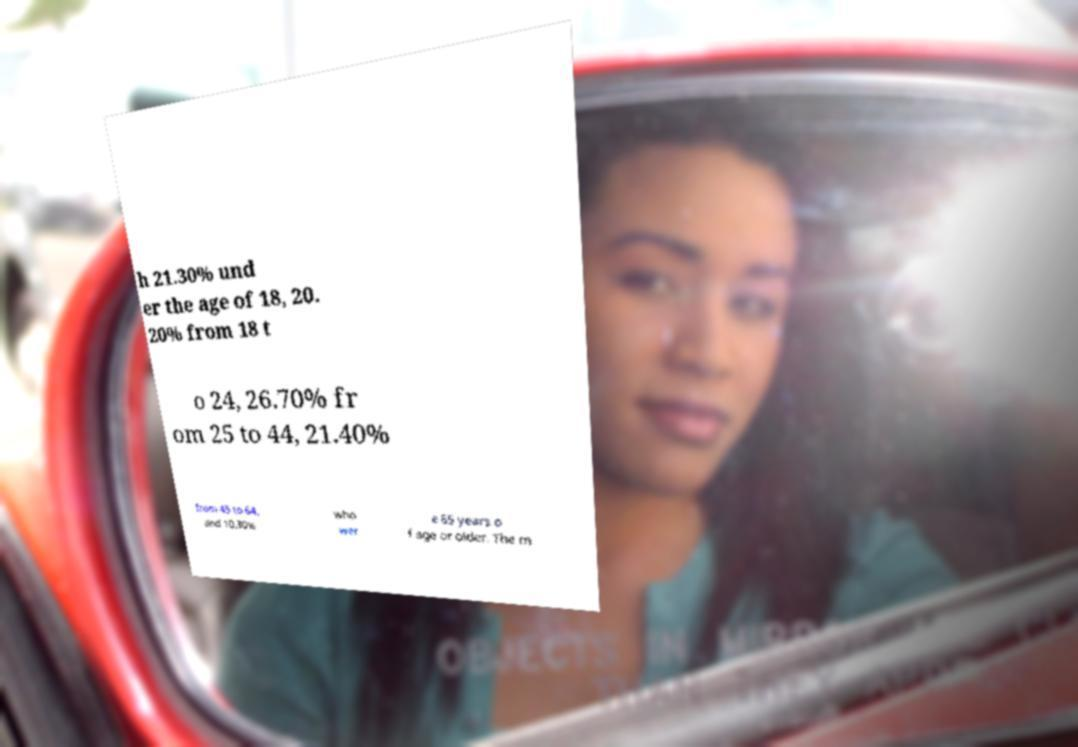I need the written content from this picture converted into text. Can you do that? h 21.30% und er the age of 18, 20. 20% from 18 t o 24, 26.70% fr om 25 to 44, 21.40% from 45 to 64, and 10.30% who wer e 65 years o f age or older. The m 